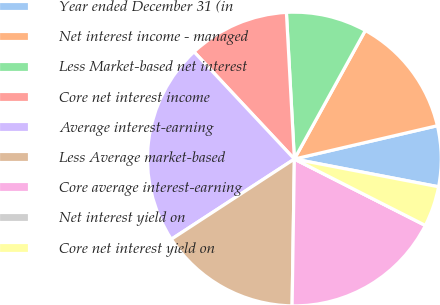<chart> <loc_0><loc_0><loc_500><loc_500><pie_chart><fcel>Year ended December 31 (in<fcel>Net interest income - managed<fcel>Less Market-based net interest<fcel>Core net interest income<fcel>Average interest-earning<fcel>Less Average market-based<fcel>Core average interest-earning<fcel>Net interest yield on<fcel>Core net interest yield on<nl><fcel>6.67%<fcel>13.33%<fcel>8.89%<fcel>11.11%<fcel>22.22%<fcel>15.56%<fcel>17.78%<fcel>0.0%<fcel>4.44%<nl></chart> 